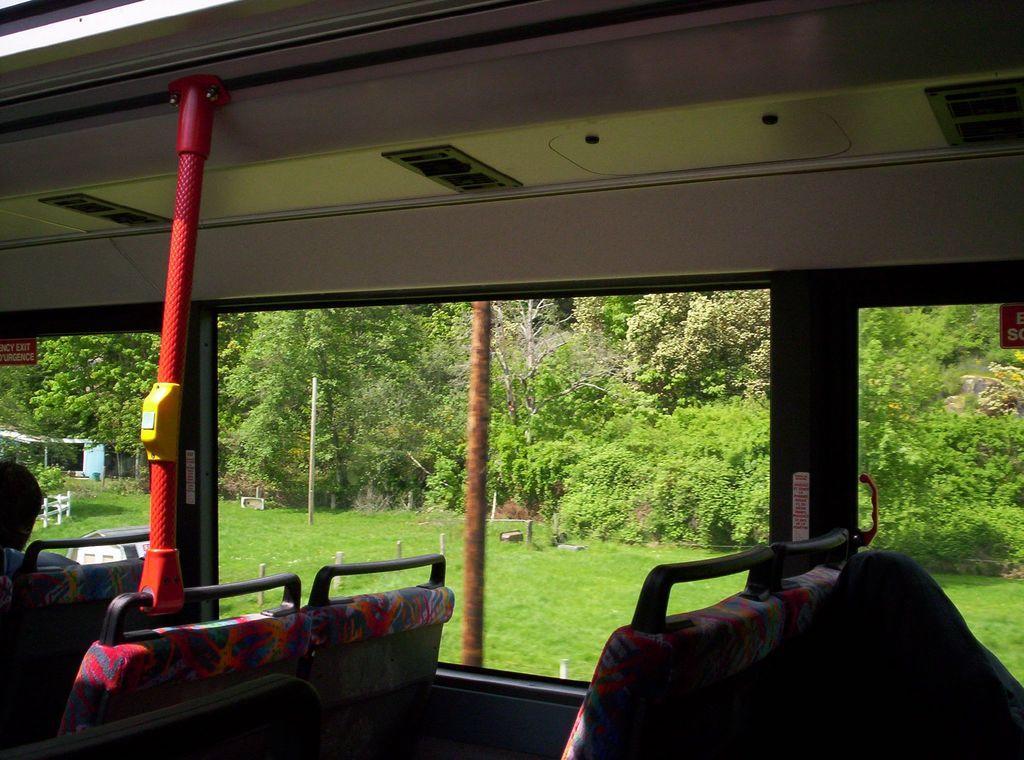Please provide a concise description of this image. A picture inside of a vehicle. Here we can see seats and rod. Through this glass windows we can see grass and trees. 